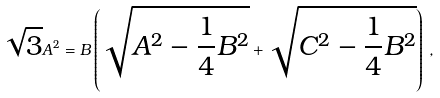Convert formula to latex. <formula><loc_0><loc_0><loc_500><loc_500>\sqrt { 3 } A ^ { 2 } = B \left ( \sqrt { A ^ { 2 } - \frac { 1 } { 4 } B ^ { 2 } } + \sqrt { { C } ^ { 2 } - \frac { 1 } { 4 } B ^ { 2 } } \right ) \, ,</formula> 